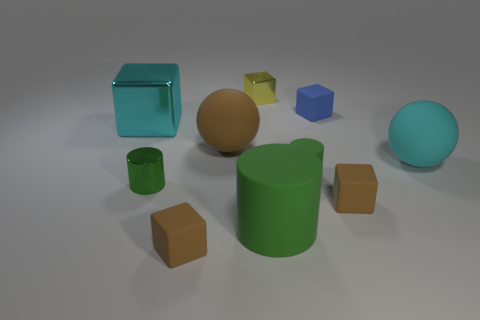What is the shape of the big cyan metal object?
Ensure brevity in your answer.  Cube. Do the big object in front of the cyan rubber sphere and the small cylinder that is on the right side of the metal cylinder have the same color?
Your answer should be compact. Yes. Is the shape of the large cyan metallic thing the same as the tiny yellow thing?
Your response must be concise. Yes. Do the small brown cube left of the small blue rubber cube and the tiny yellow cube have the same material?
Offer a very short reply. No. What is the shape of the matte object that is in front of the large cyan matte ball and to the right of the blue rubber object?
Make the answer very short. Cube. Are there any small shiny cubes that are in front of the metal thing that is behind the blue block?
Ensure brevity in your answer.  No. How many other things are there of the same material as the small yellow cube?
Ensure brevity in your answer.  2. Is the shape of the small green object on the left side of the brown sphere the same as the green object that is to the right of the big rubber cylinder?
Your answer should be very brief. Yes. Is the material of the large green thing the same as the small blue cube?
Your response must be concise. Yes. There is a green cylinder on the right side of the big thing in front of the cyan thing on the right side of the tiny yellow cube; how big is it?
Your response must be concise. Small. 